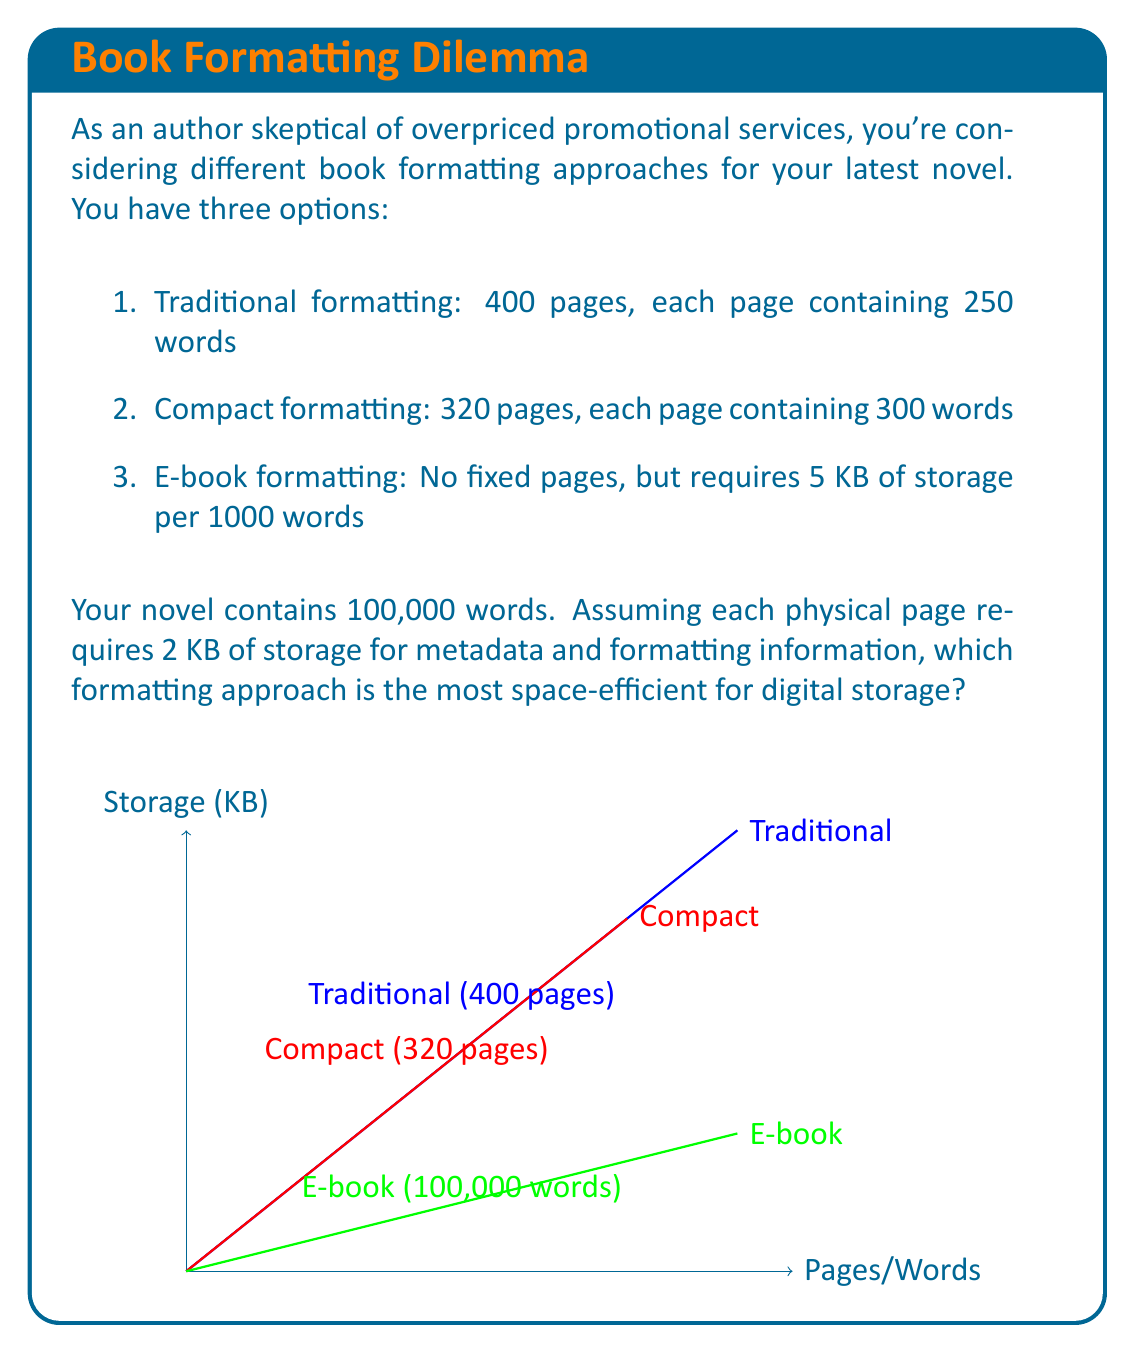Solve this math problem. Let's analyze each formatting approach:

1. Traditional formatting:
   - Number of pages: $\frac{100,000 \text{ words}}{250 \text{ words/page}} = 400 \text{ pages}$
   - Storage required: $400 \text{ pages} \times 2 \text{ KB/page} = 800 \text{ KB}$

2. Compact formatting:
   - Number of pages: $\frac{100,000 \text{ words}}{300 \text{ words/page}} = 333.33 \text{ pages}$ (rounded to 334)
   - Storage required: $334 \text{ pages} \times 2 \text{ KB/page} = 668 \text{ KB}$

3. E-book formatting:
   - Storage required: $\frac{100,000 \text{ words}}{1000 \text{ words}} \times 5 \text{ KB} = 500 \text{ KB}$

The e-book formatting approach requires the least amount of storage (500 KB) compared to the traditional (800 KB) and compact (668 KB) formatting approaches. This is because the e-book format eliminates the need for fixed pages and their associated metadata, resulting in a more space-efficient storage solution.

The space efficiency can be expressed as a ratio of words stored per KB:

$\text{E-book efficiency} = \frac{100,000 \text{ words}}{500 \text{ KB}} = 200 \text{ words/KB}$

$\text{Compact efficiency} = \frac{100,000 \text{ words}}{668 \text{ KB}} \approx 149.7 \text{ words/KB}$

$\text{Traditional efficiency} = \frac{100,000 \text{ words}}{800 \text{ KB}} = 125 \text{ words/KB}$

The e-book format is approximately 33.6% more space-efficient than the compact format and 60% more space-efficient than the traditional format.
Answer: E-book formatting (500 KB) 